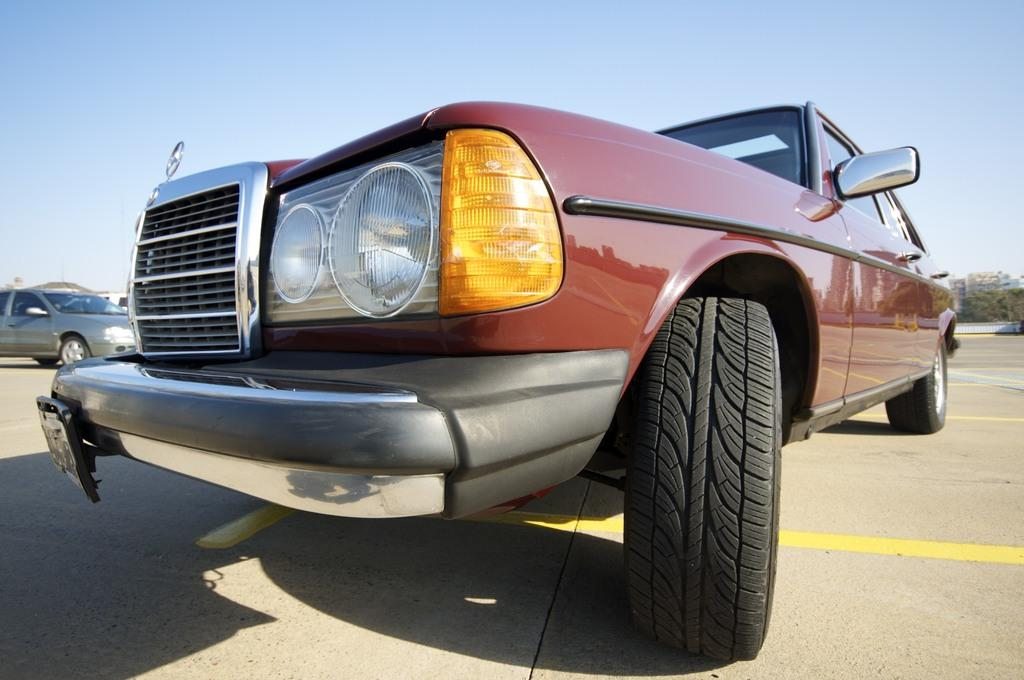What can be seen parked on the road in the image? There are cars parked on the road in the image. What is visible behind the parked cars? There are trees visible behind the parked cars. What is the condition of the sky in the image? The sky is clear in the image. How many cats can be seen playing with an agreement in the image? There are no cats or agreements present in the image. What type of class is being held in the image? There is no class being held in the image; it features parked cars on the road with trees and a clear sky in the background. 